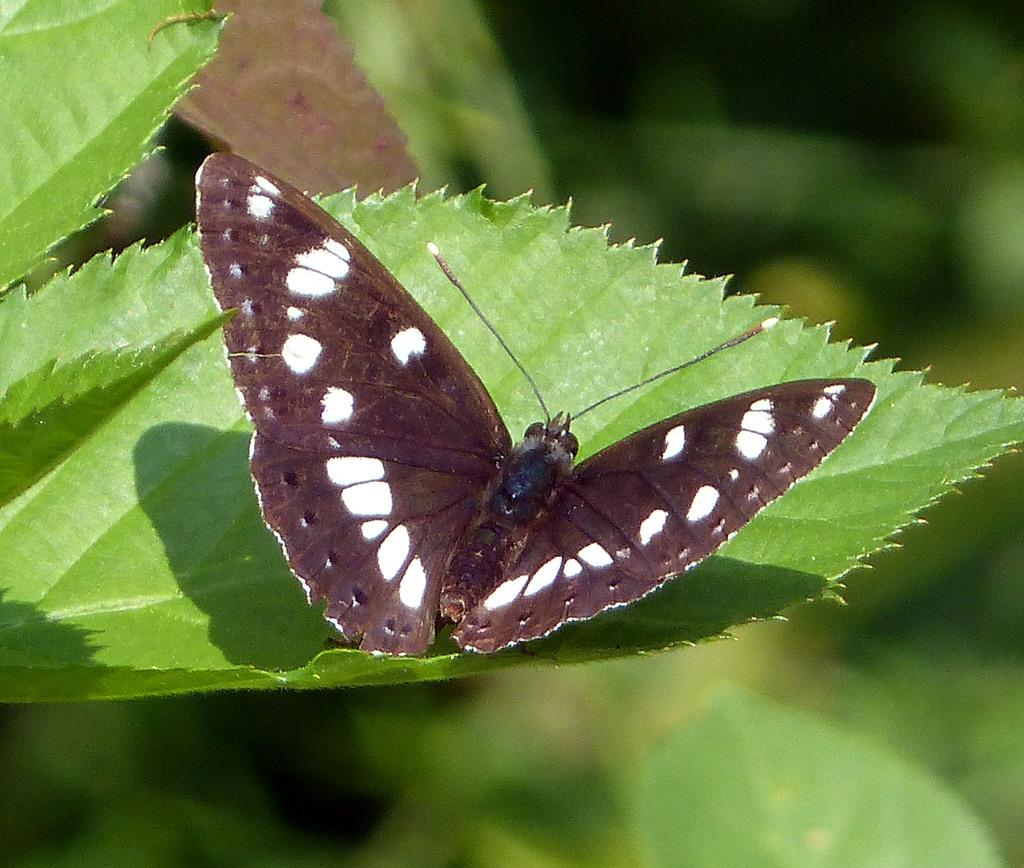What is the main subject of the image? There is a butterfly in the image. Where is the butterfly located? The butterfly is on a leaf. What type of cream is the girl using to make her aunt's favorite dessert in the image? There is no girl, cream, or dessert present in the image; it only features a butterfly on a leaf. 